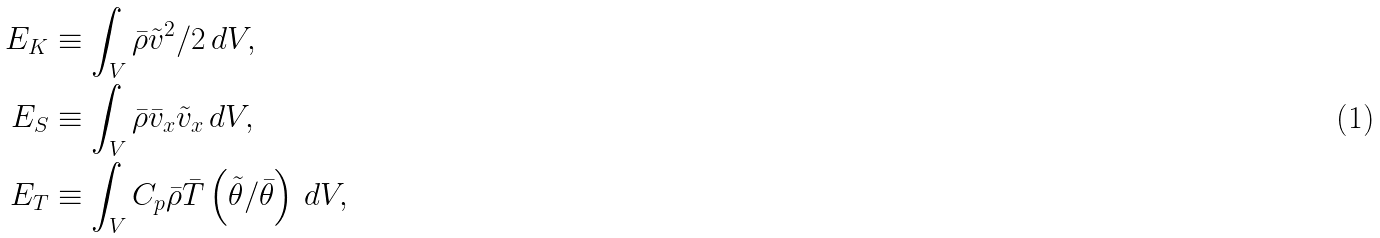Convert formula to latex. <formula><loc_0><loc_0><loc_500><loc_500>E _ { K } & \equiv \int _ { V } \bar { \rho } \tilde { v } ^ { 2 } / 2 \, d V , \\ E _ { S } & \equiv \int _ { V } \bar { \rho } \bar { v } _ { x } \tilde { v } _ { x } \, d V , \\ E _ { T } & \equiv \int _ { V } C _ { p } \bar { \rho } \bar { T } \left ( \tilde { \theta } / \bar { \theta } \right ) \, d V ,</formula> 